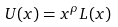<formula> <loc_0><loc_0><loc_500><loc_500>U ( x ) = x ^ { \rho } L ( x )</formula> 